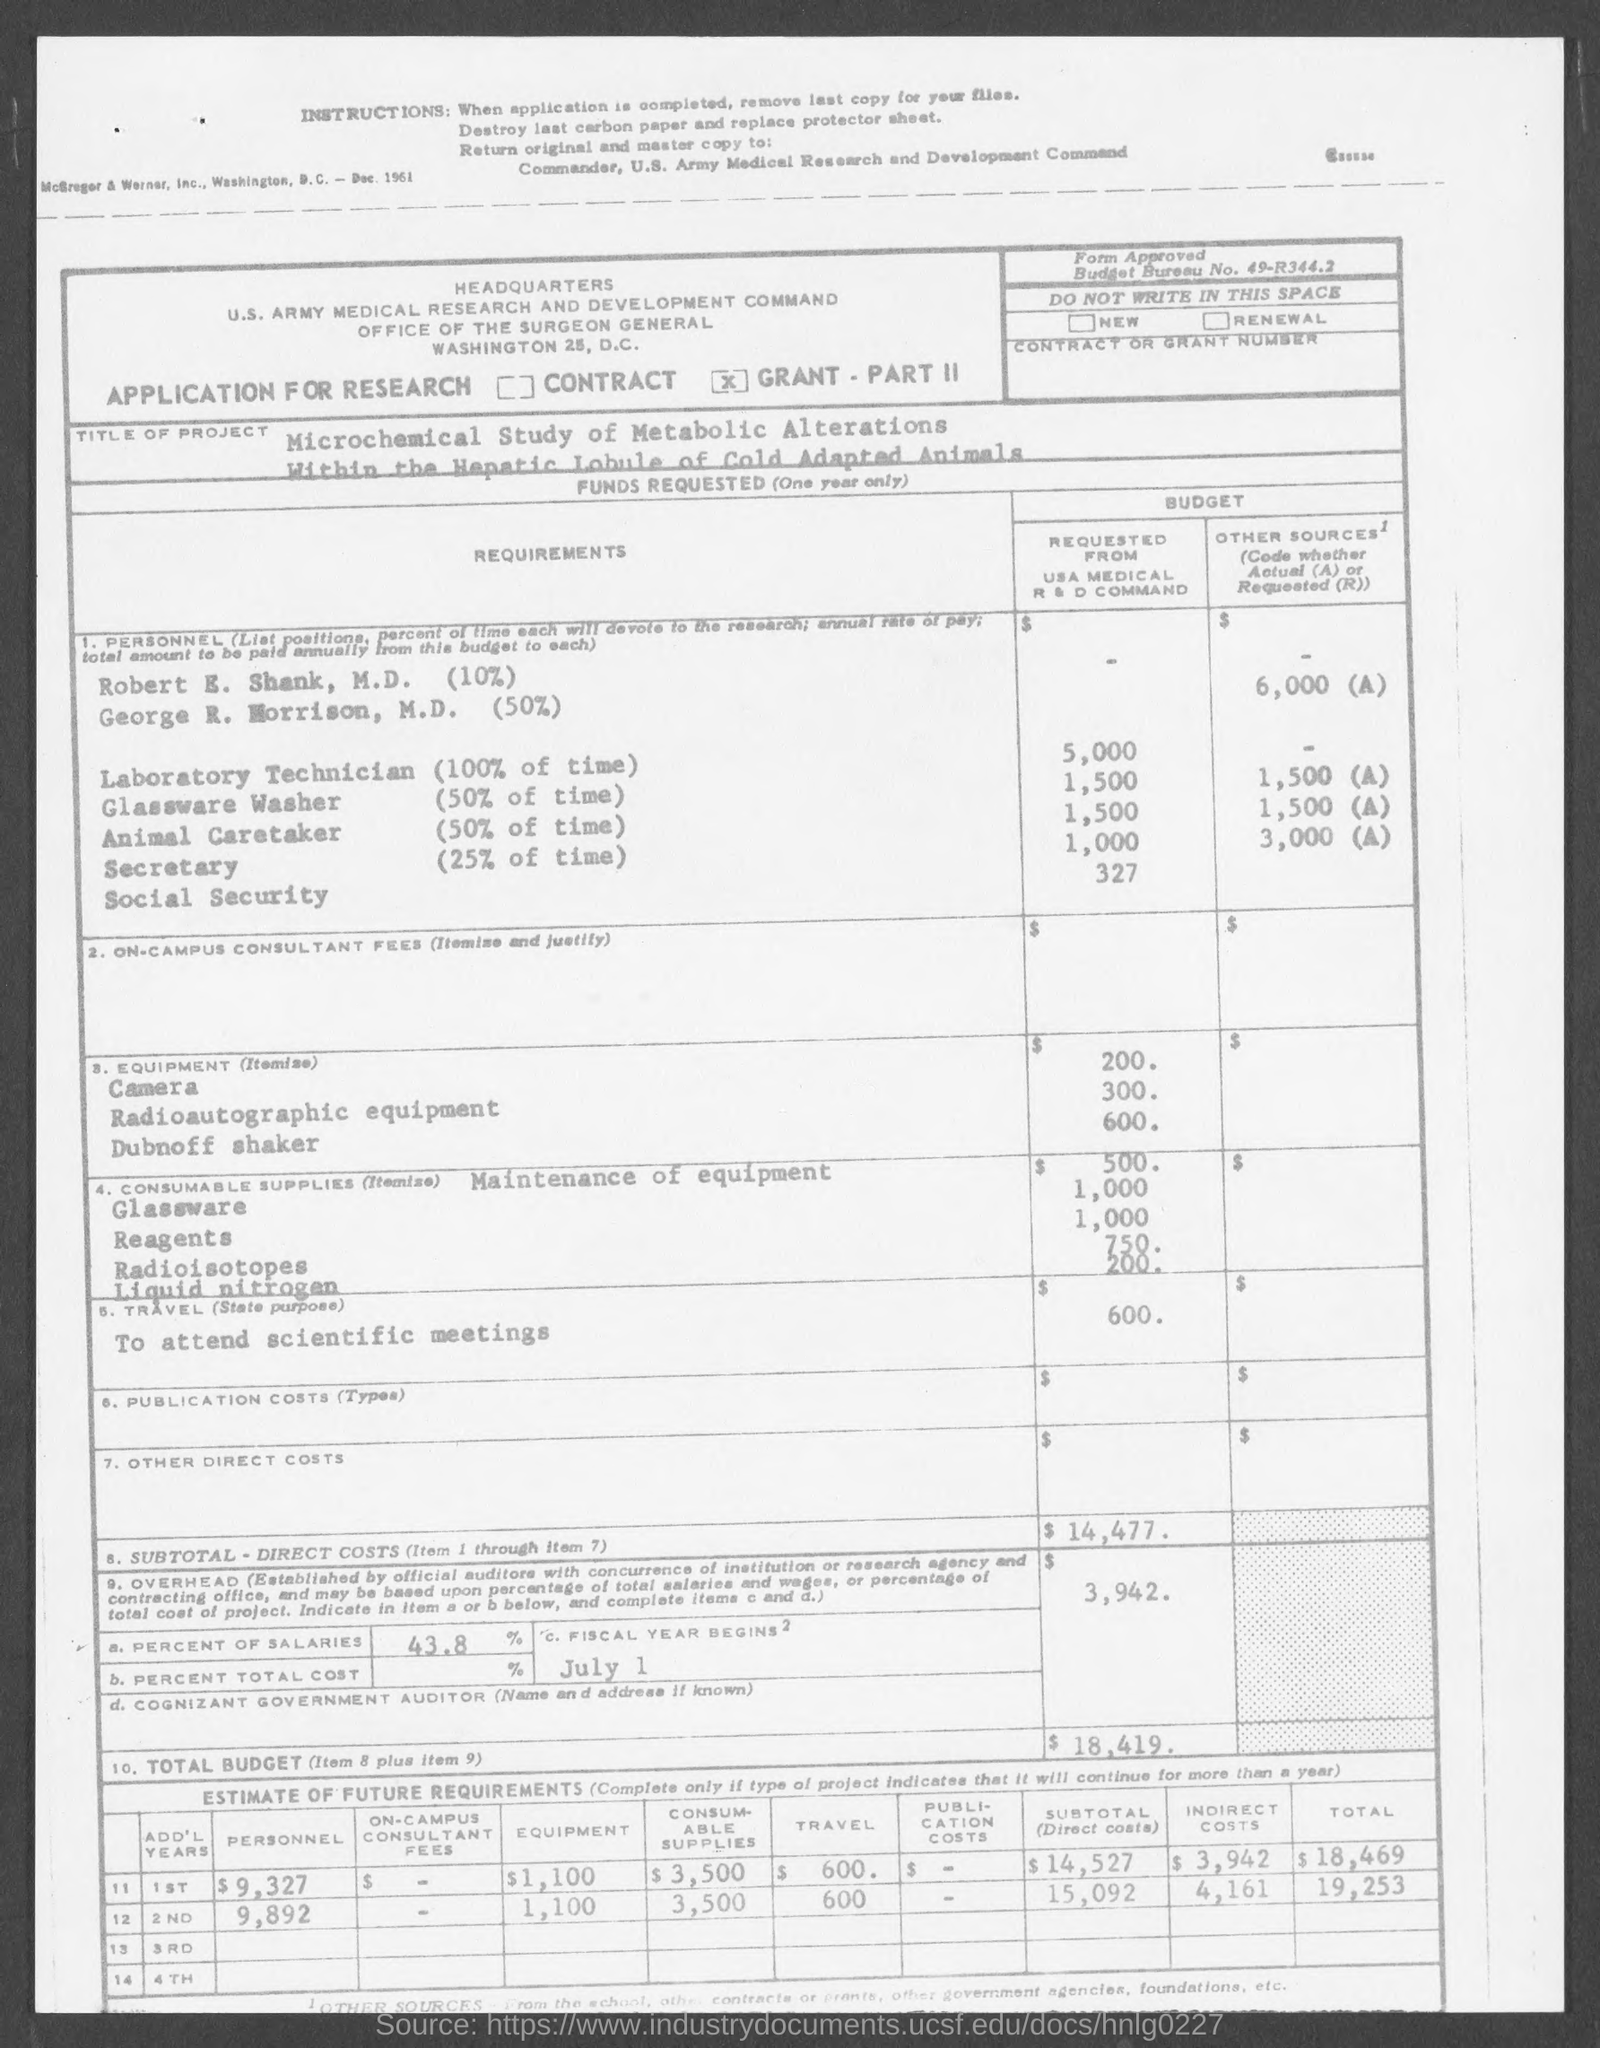What is the title of the project mentioned in the given page ?
Make the answer very short. Microchemical study of metabolic alterations within the hepatic lobule of cold adapted animals. What is the amount of budget requested from usa medical r&d command for laboratory technician ?
Your answer should be compact. 5,000. What is the amount of budget requested from usa medical r&d command for glassware washer ?
Make the answer very short. $1,500. What is the amount of budget requested from usa medical r&d command for animal caretaker ?
Provide a succinct answer. $ 1,500. What is the amount of budget requested from usa medical r&d command for secretary?
Make the answer very short. 1,000. What is the amount requested from usa medical r&d command for camera ?
Your answer should be very brief. $200. What is the sub total -direct costs mentioned in the given page ?
Your response must be concise. $14,477. What is the percent of salaries mentioned in the given page ?
Give a very brief answer. 43.8%. When will the fiscal year begins as mentioned in the given page ?
Your answer should be compact. JULY 1. 